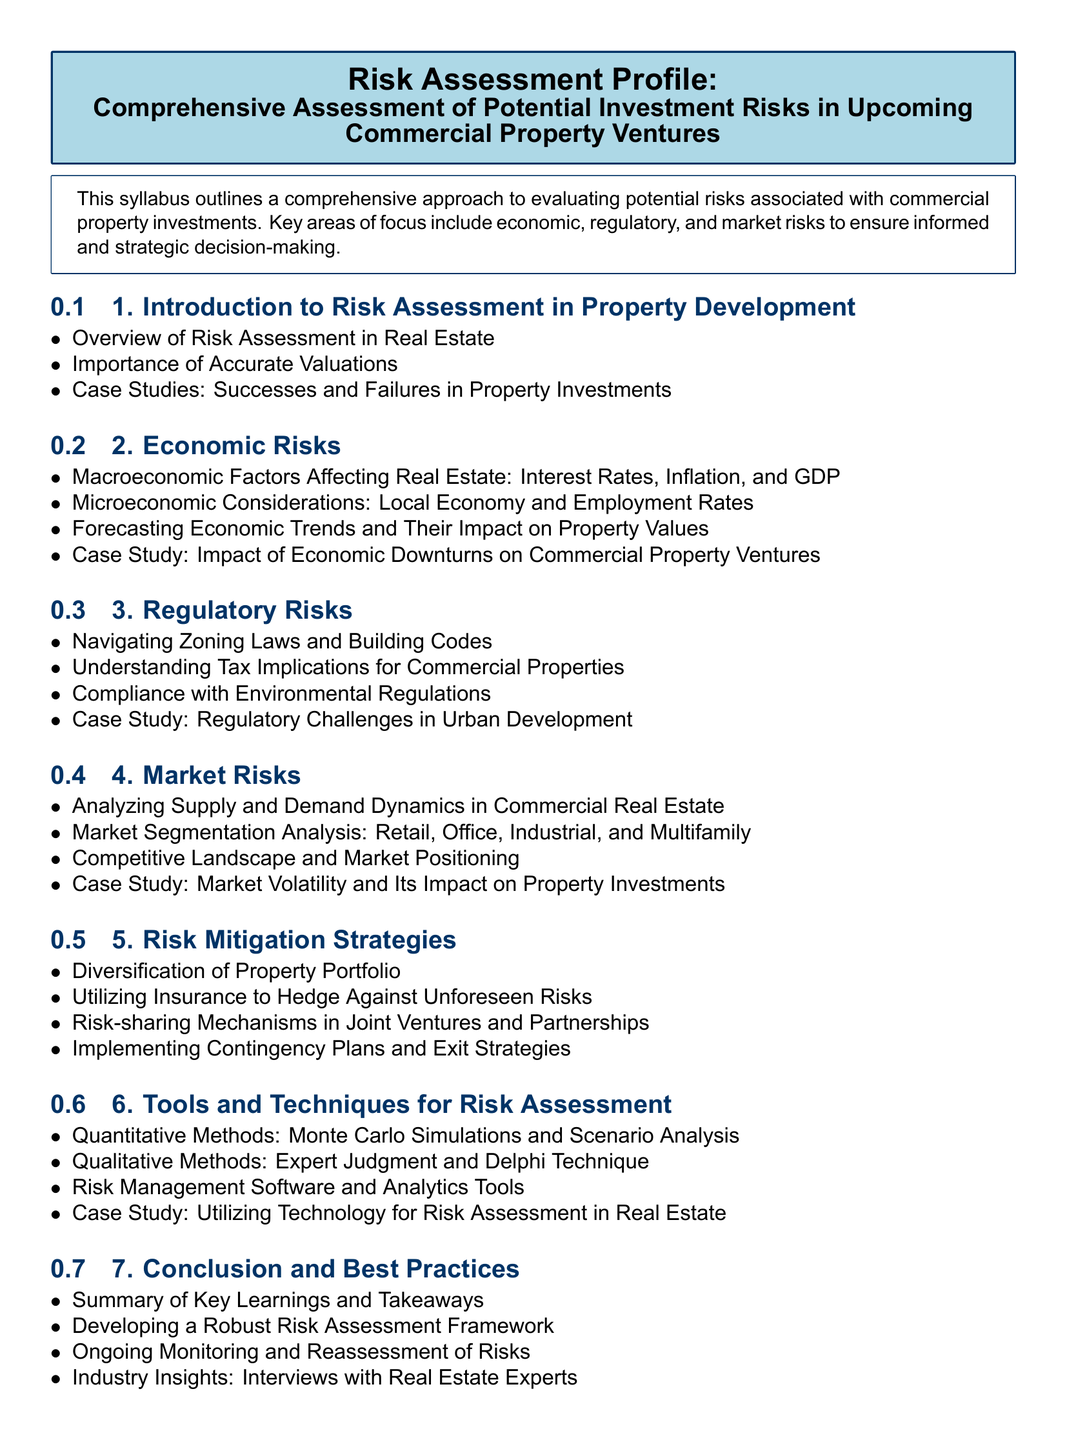What is the title of the document? The title of the document is clearly stated at the beginning, indicating the focus on risk assessment in property ventures.
Answer: Risk Assessment Profile: Comprehensive Assessment of Potential Investment Risks in Upcoming Commercial Property Ventures How many main modules are there in the syllabus? The syllabus lists a total of seven modules for the risk assessment profile.
Answer: 7 Which module discusses economic downturns? The module that specifically addresses economic downturns and their effects on property is highlighted under economic risks.
Answer: Economic Risks What is a key strategy discussed for risk mitigation? The syllabus mentions diversifying the property portfolio as a critical strategy for mitigating risks associated with property investments.
Answer: Diversification of Property Portfolio What type of analysis is mentioned under quantitative methods? The syllabus specifies Monte Carlo simulations as a method employed for quantitative risk assessment in real estate.
Answer: Monte Carlo Simulations Which case study focuses on regulatory challenges? The syllabus indicates that there is a case study dedicated to examining regulatory challenges in urban development.
Answer: Regulatory Challenges in Urban Development What is emphasized in the conclusion of the syllabus? The conclusion emphasizes developing a robust framework for ongoing monitoring and reassessment of risks in property development.
Answer: Developing a Robust Risk Assessment Framework 